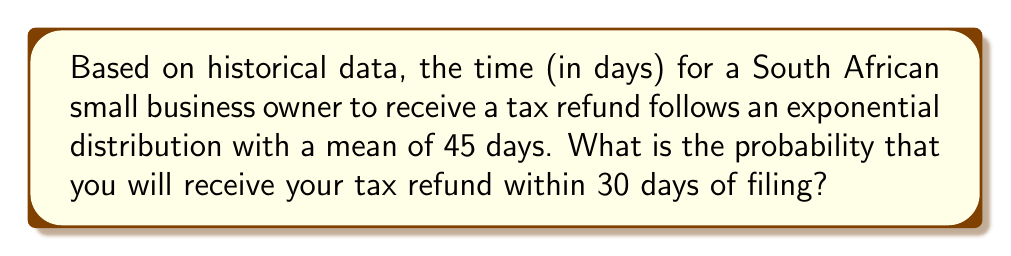Solve this math problem. To solve this problem, we'll use the properties of the exponential distribution:

1) The exponential distribution has a probability density function:
   $$f(x) = \lambda e^{-\lambda x}$$
   where $\lambda$ is the rate parameter.

2) The mean of an exponential distribution is $\frac{1}{\lambda}$.

3) Given that the mean is 45 days, we can calculate $\lambda$:
   $$\lambda = \frac{1}{45} \approx 0.0222$$

4) The cumulative distribution function (CDF) of the exponential distribution is:
   $$F(x) = 1 - e^{-\lambda x}$$

5) To find the probability of receiving the refund within 30 days, we need to calculate:
   $$P(X \leq 30) = F(30) = 1 - e^{-\lambda \cdot 30}$$

6) Substituting the values:
   $$P(X \leq 30) = 1 - e^{-0.0222 \cdot 30}$$
   $$= 1 - e^{-0.666}$$
   $$= 1 - 0.5139$$
   $$= 0.4861$$

Therefore, the probability of receiving your tax refund within 30 days is approximately 0.4861 or 48.61%.
Answer: $P(X \leq 30) \approx 0.4861$ or $48.61\%$ 